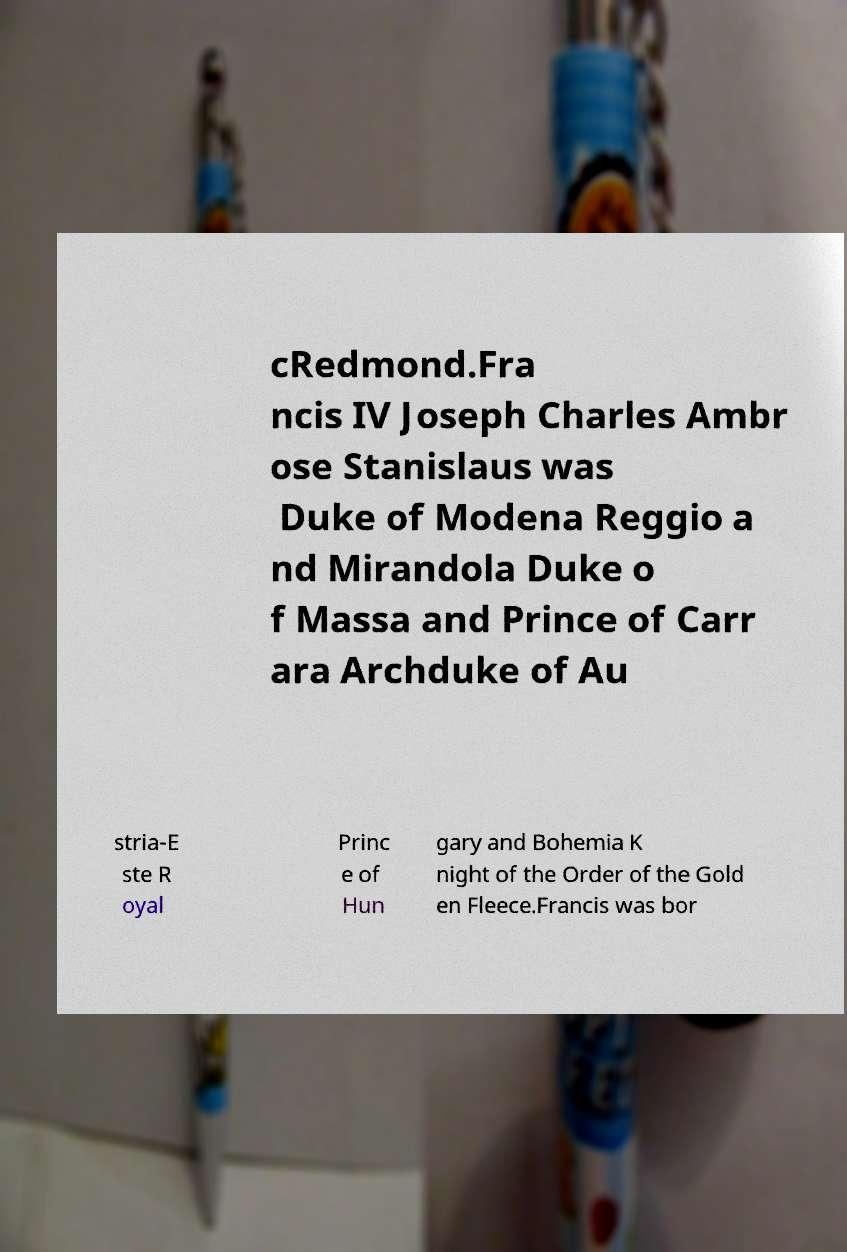Can you accurately transcribe the text from the provided image for me? cRedmond.Fra ncis IV Joseph Charles Ambr ose Stanislaus was Duke of Modena Reggio a nd Mirandola Duke o f Massa and Prince of Carr ara Archduke of Au stria-E ste R oyal Princ e of Hun gary and Bohemia K night of the Order of the Gold en Fleece.Francis was bor 